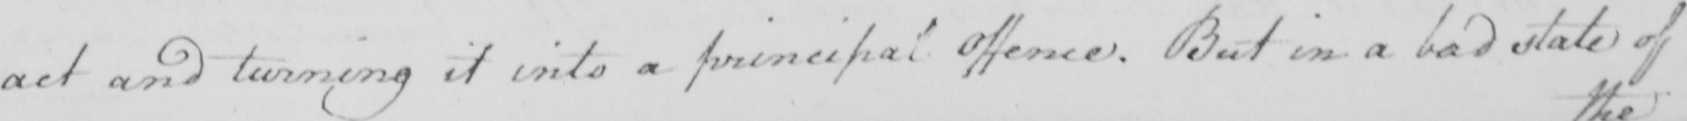Please transcribe the handwritten text in this image. act and turning it into a principal Offence . But in a bad state of 